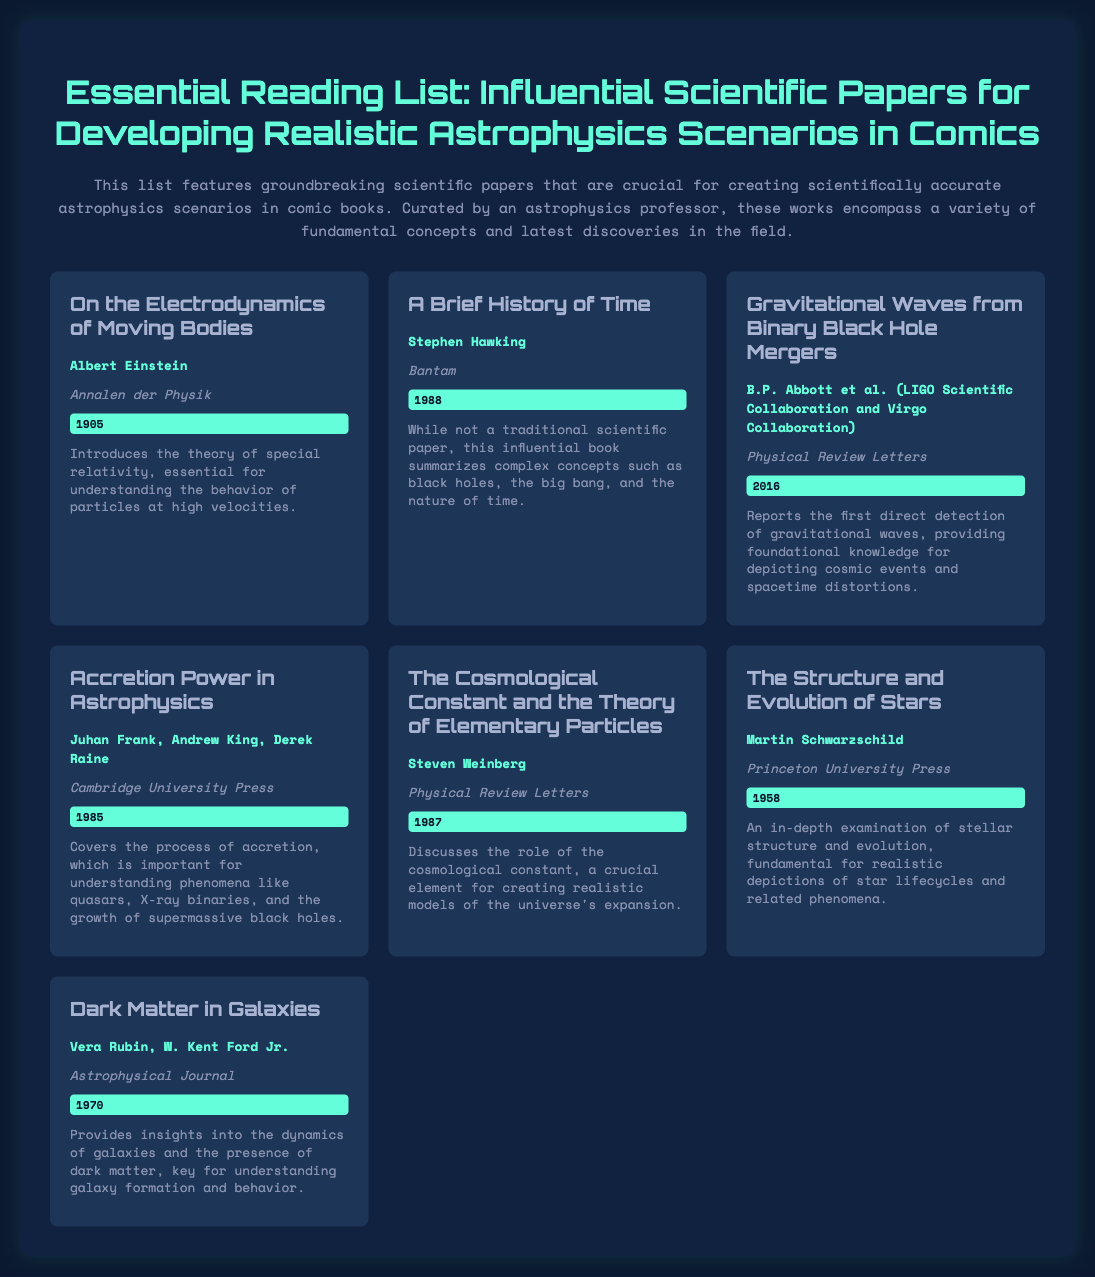What is the title of the first paper listed? The first paper listed is titled "On the Electrodynamics of Moving Bodies."
Answer: On the Electrodynamics of Moving Bodies Who is the author of "A Brief History of Time"? "A Brief History of Time" is authored by Stephen Hawking.
Answer: Stephen Hawking In what year was the paper "Gravitational Waves from Binary Black Hole Mergers" published? This paper was published in 2016.
Answer: 2016 What is the main topic of the paper by Juhan Frank, Andrew King, and Derek Raine? The paper by Juhan Frank, Andrew King, and Derek Raine discusses accretion power in astrophysics.
Answer: Accretion Power Which journal published the paper "Dark Matter in Galaxies"? The paper "Dark Matter in Galaxies" was published in the Astrophysical Journal.
Answer: Astrophysical Journal How many authors contributed to the paper discussing gravitational waves? The paper "Gravitational Waves from Binary Black Hole Mergers" has multiple authors, specifically listed as B.P. Abbott et al.
Answer: multiple Who authored the paper "The Cosmological Constant and the Theory of Elementary Particles"? The author of the paper is Steven Weinberg.
Answer: Steven Weinberg What type of document is being described? The document is an essential reading list for scientific papers in astrophysics.
Answer: essential reading list 